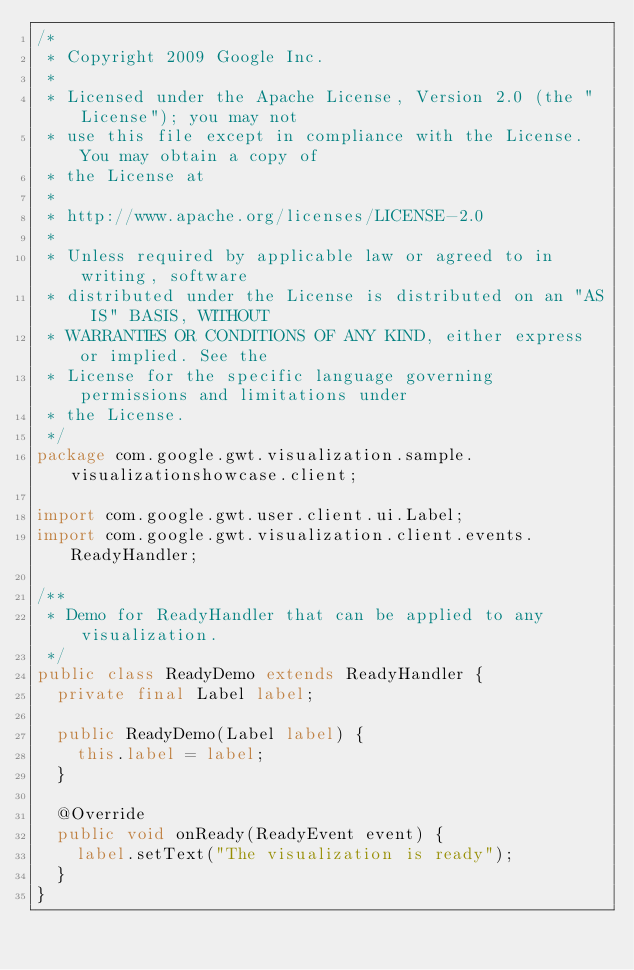Convert code to text. <code><loc_0><loc_0><loc_500><loc_500><_Java_>/*
 * Copyright 2009 Google Inc.
 * 
 * Licensed under the Apache License, Version 2.0 (the "License"); you may not
 * use this file except in compliance with the License. You may obtain a copy of
 * the License at
 * 
 * http://www.apache.org/licenses/LICENSE-2.0
 * 
 * Unless required by applicable law or agreed to in writing, software
 * distributed under the License is distributed on an "AS IS" BASIS, WITHOUT
 * WARRANTIES OR CONDITIONS OF ANY KIND, either express or implied. See the
 * License for the specific language governing permissions and limitations under
 * the License.
 */
package com.google.gwt.visualization.sample.visualizationshowcase.client;

import com.google.gwt.user.client.ui.Label;
import com.google.gwt.visualization.client.events.ReadyHandler;

/**
 * Demo for ReadyHandler that can be applied to any visualization.
 */
public class ReadyDemo extends ReadyHandler {
  private final Label label;

  public ReadyDemo(Label label) {
    this.label = label;
  }

  @Override
  public void onReady(ReadyEvent event) {
    label.setText("The visualization is ready"); 
  }
}
</code> 